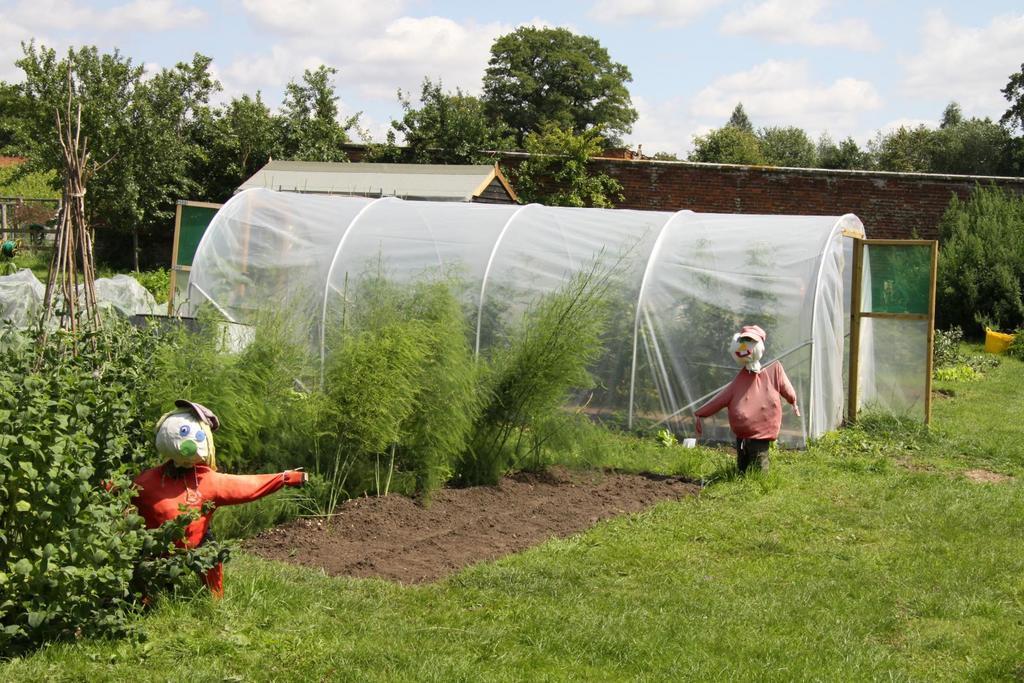How would you summarize this image in a sentence or two? At the center of the image there is a net like a camp with a door, in that there are plants, around that there are trees, plants, grass, depiction of persons, sticks, a shed and a wall with red bricks. In the background there are trees and the sky. 